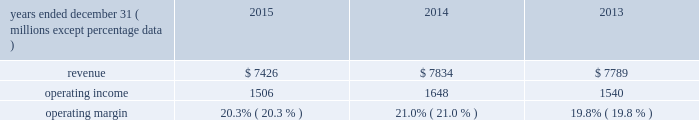( 2 ) in 2013 , our principal u.k subsidiary agreed with the trustees of one of the u.k .
Plans to contribute an average of $ 11 million per year to that pension plan for the next three years .
The trustees of the plan have certain rights to request that our u.k .
Subsidiary advance an amount equal to an actuarially determined winding-up deficit .
As of december 31 , 2015 , the estimated winding-up deficit was a3240 million ( $ 360 million at december 31 , 2015 exchange rates ) .
The trustees of the plan have accepted in practice the agreed-upon schedule of contributions detailed above and have not requested the winding-up deficit be paid .
( 3 ) purchase obligations are defined as agreements to purchase goods and services that are enforceable and legally binding on us , and that specifies all significant terms , including what is to be purchased , at what price and the approximate timing of the transaction .
Most of our purchase obligations are related to purchases of information technology services or other service contracts .
( 4 ) excludes $ 12 million of unfunded commitments related to an investment in a limited partnership due to our inability to reasonably estimate the period ( s ) when the limited partnership will request funding .
( 5 ) excludes $ 218 million of liabilities for uncertain tax positions due to our inability to reasonably estimate the period ( s ) when potential cash settlements will be made .
Financial condition at december 31 , 2015 , our net assets were $ 6.2 billion , representing total assets minus total liabilities , a decrease from $ 6.6 billion at december 31 , 2014 .
The decrease was due primarily to share repurchases of $ 1.6 billion , dividends of $ 323 million , and an increase in accumulated other comprehensive loss of $ 289 million related primarily to an increase in the post- retirement benefit obligation , partially offset by net income of $ 1.4 billion for the year ended december 31 , 2015 .
Working capital increased by $ 77 million from $ 809 million at december 31 , 2014 to $ 886 million at december 31 , 2015 .
Accumulated other comprehensive loss increased $ 289 million at december 31 , 2015 as compared to december 31 , 2014 , which was primarily driven by the following : 2022 negative net foreign currency translation adjustments of $ 436 million , which are attributable to the strengthening of the u.s .
Dollar against certain foreign currencies , 2022 a decrease of $ 155 million in net post-retirement benefit obligations , and 2022 net financial instrument losses of $ 8 million .
Review by segment general we serve clients through the following segments : 2022 risk solutions acts as an advisor and insurance and reinsurance broker , helping clients manage their risks , via consultation , as well as negotiation and placement of insurance risk with insurance carriers through our global distribution network .
2022 hr solutions partners with organizations to solve their most complex benefits , talent and related financial challenges , and improve business performance by designing , implementing , communicating and administering a wide range of human capital , retirement , investment management , health care , compensation and talent management strategies .
Risk solutions .
The demand for property and casualty insurance generally rises as the overall level of economic activity increases and generally falls as such activity decreases , affecting both the commissions and fees generated by our brokerage business .
The economic activity that impacts property and casualty insurance is described as exposure units , and is most closely correlated .
What is the net income margin for 2015? 
Computations: ((1.4 * 1000) / 7426)
Answer: 0.18853. 